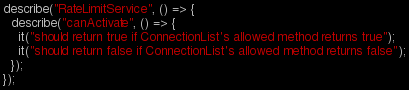<code> <loc_0><loc_0><loc_500><loc_500><_TypeScript_>describe("RateLimitService", () => {
  describe("canActivate", () => {
    it("should return true if ConnectionList's allowed method returns true");
    it("should return false if ConnectionList's allowed method returns false");
  });
});
</code> 